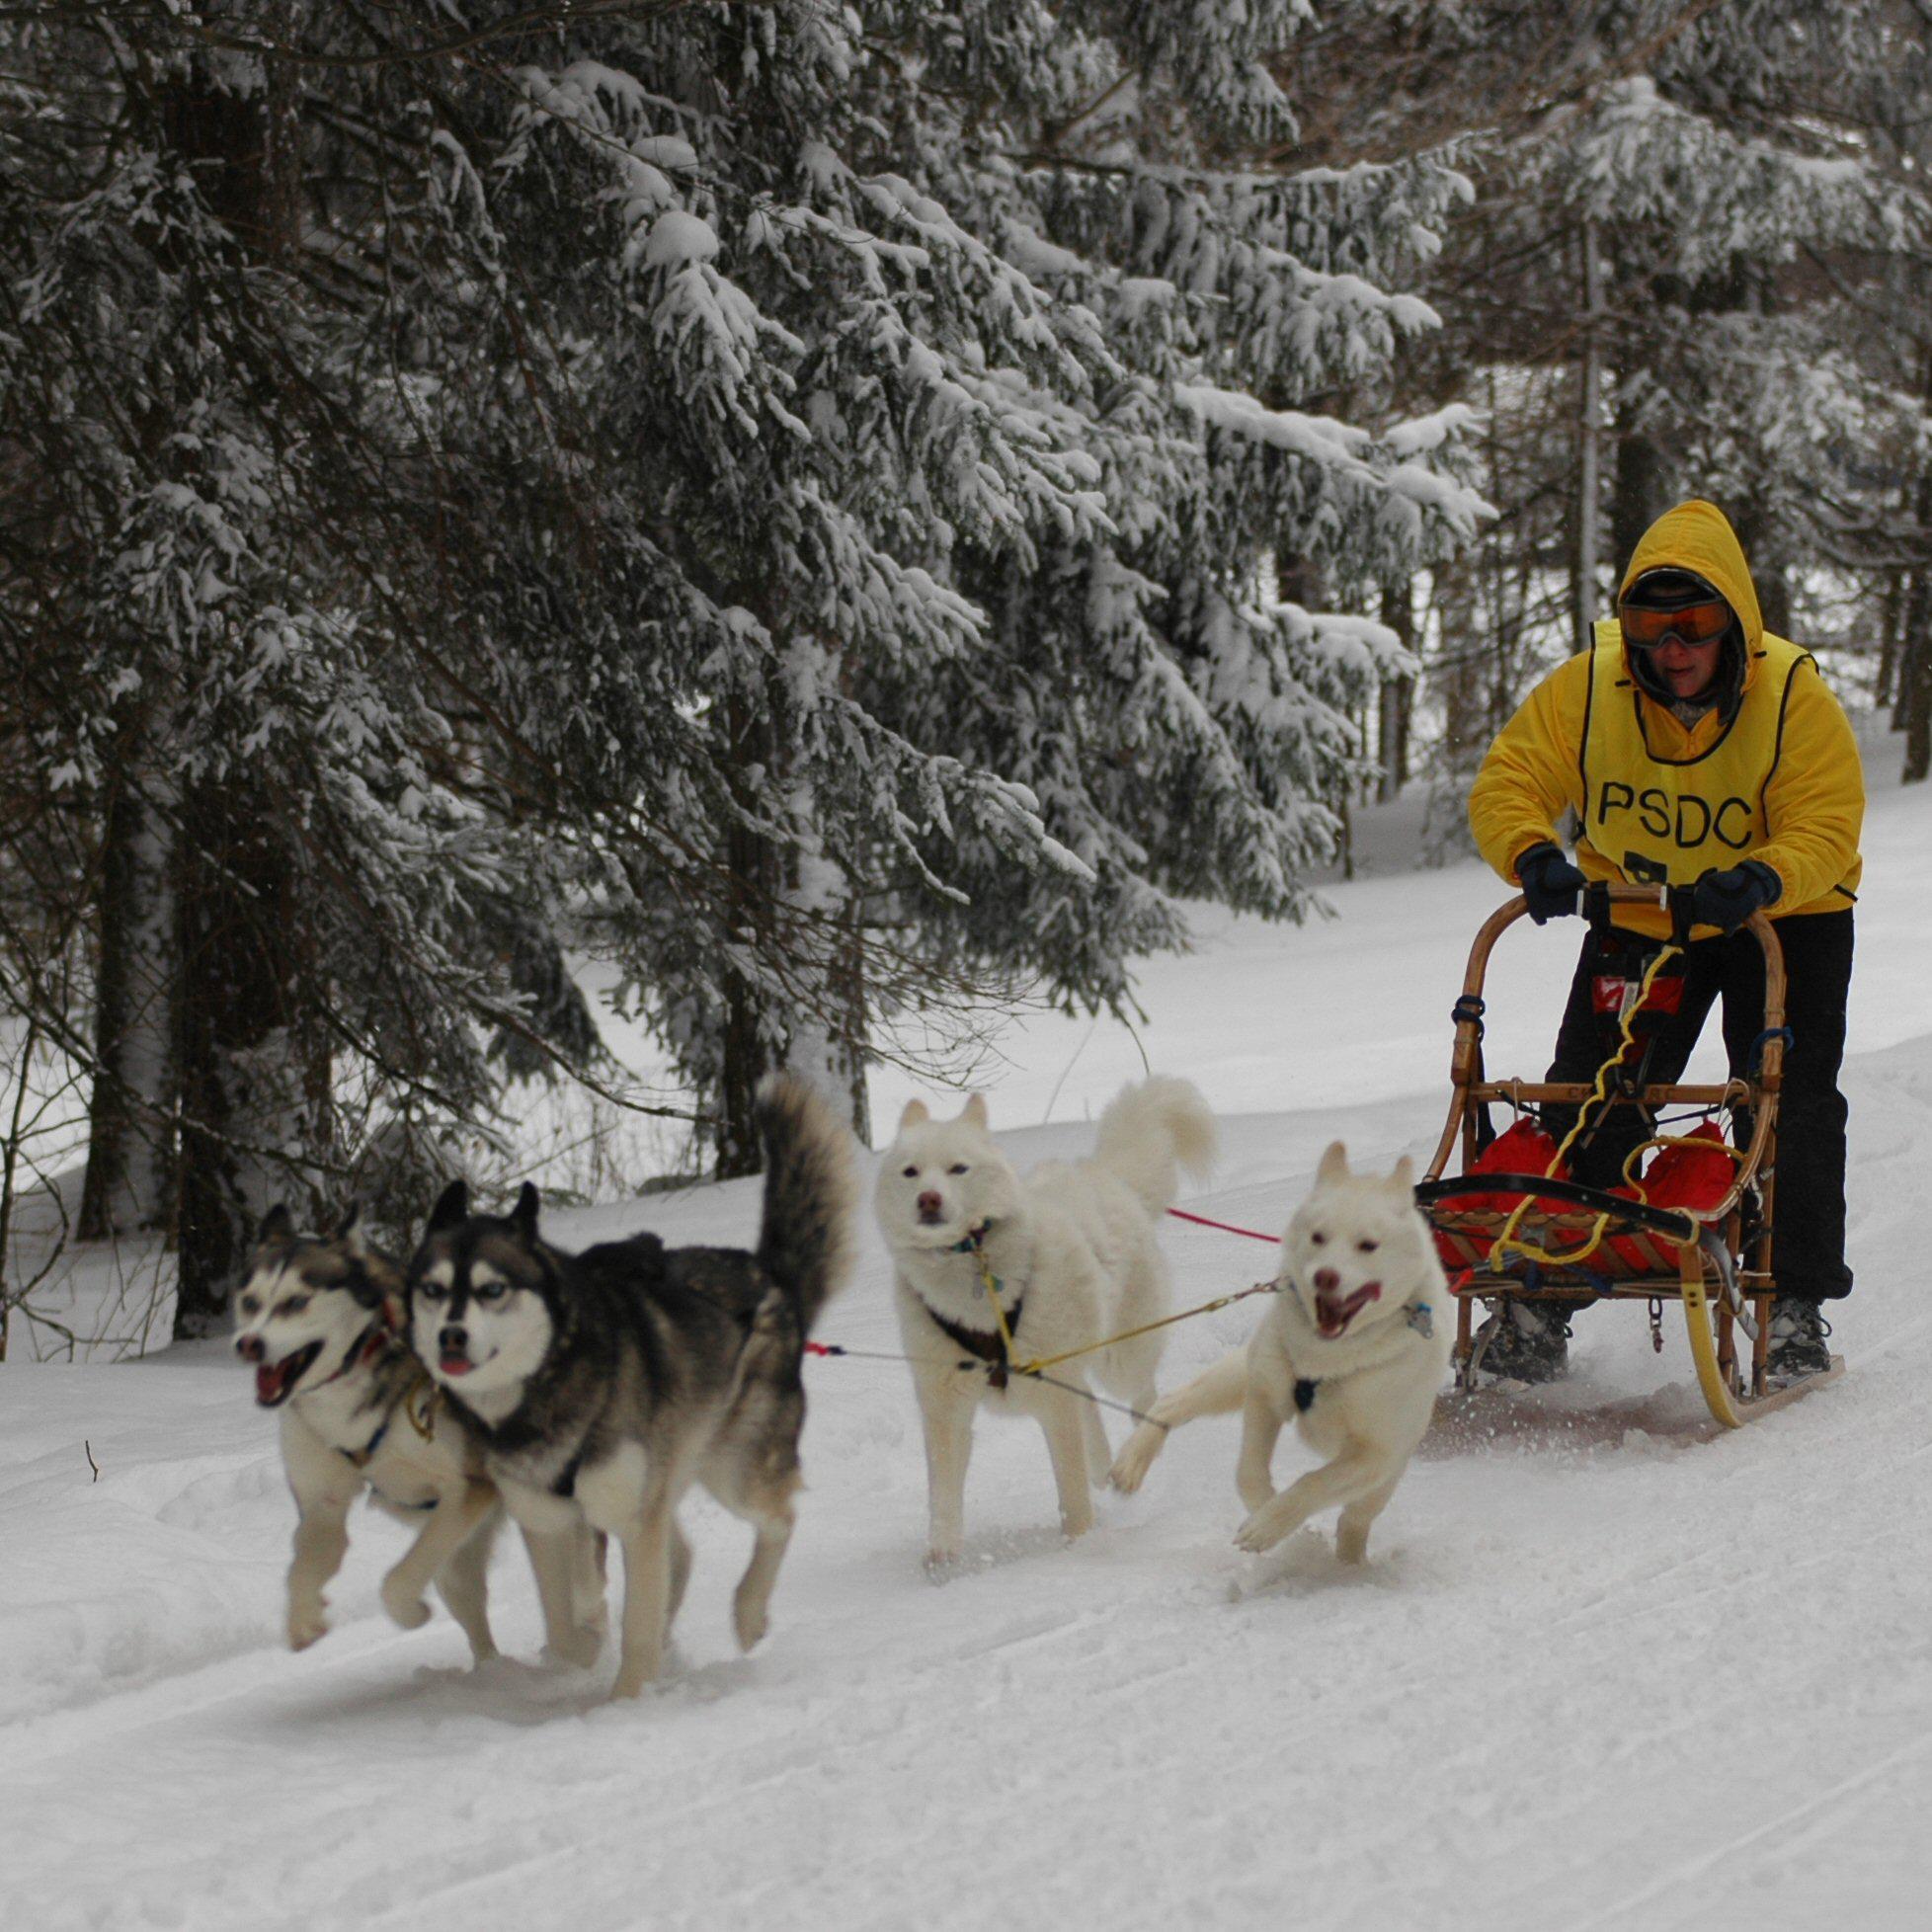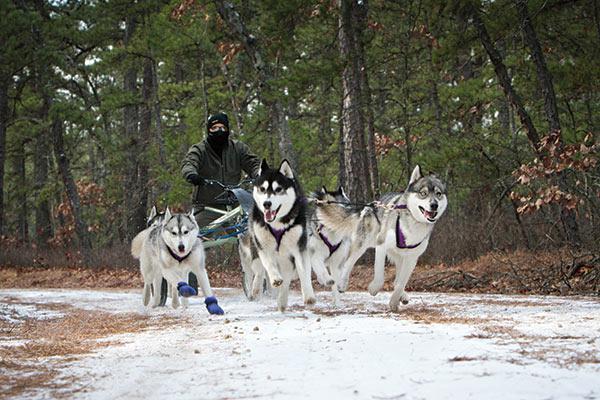The first image is the image on the left, the second image is the image on the right. Considering the images on both sides, is "The left image contains exactly four sled dogs." valid? Answer yes or no. Yes. The first image is the image on the left, the second image is the image on the right. Assess this claim about the two images: "Non-snow-covered evergreens and a flat horizon are behind one of the sled dog teams.". Correct or not? Answer yes or no. Yes. 